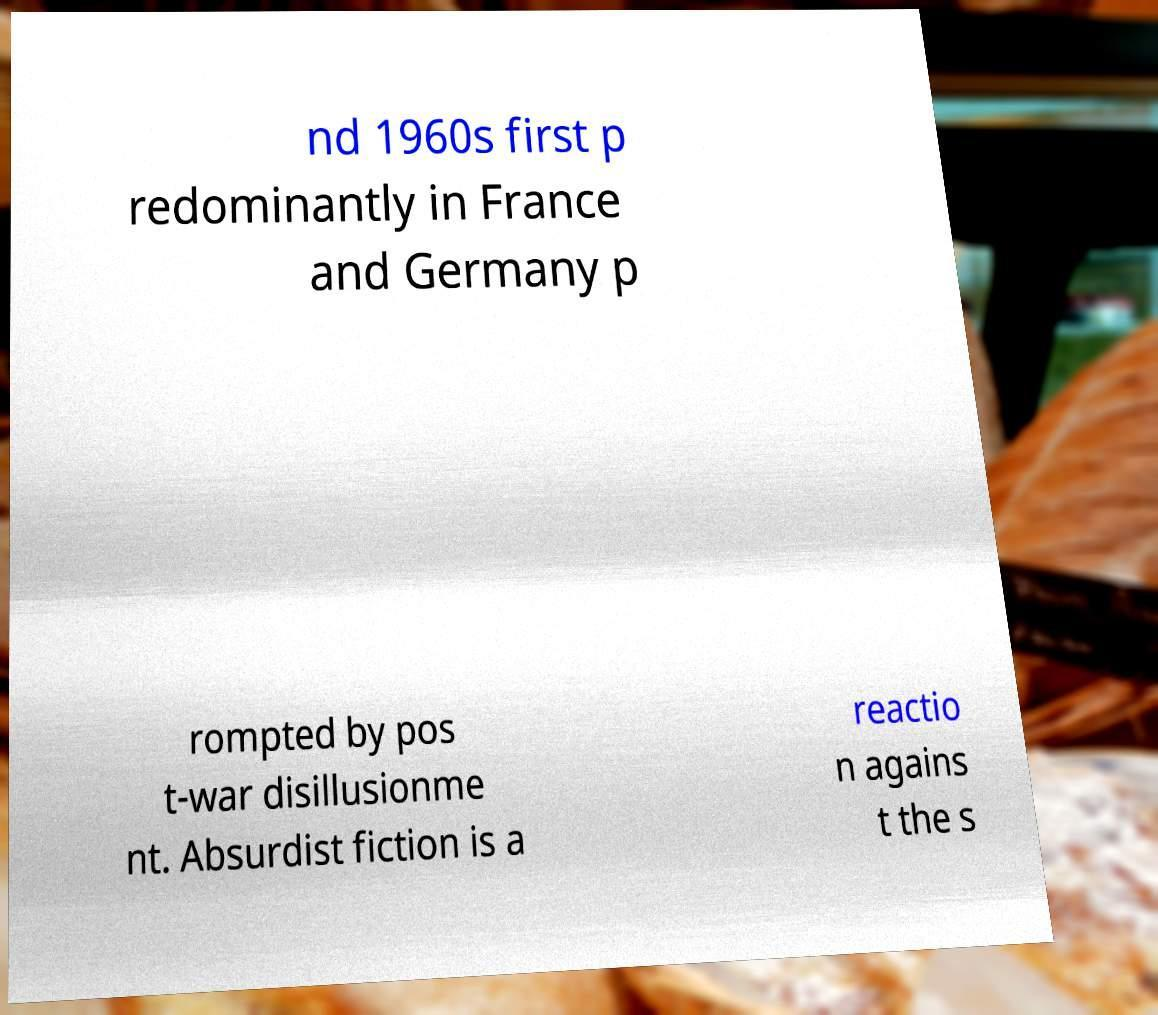I need the written content from this picture converted into text. Can you do that? nd 1960s first p redominantly in France and Germany p rompted by pos t-war disillusionme nt. Absurdist fiction is a reactio n agains t the s 